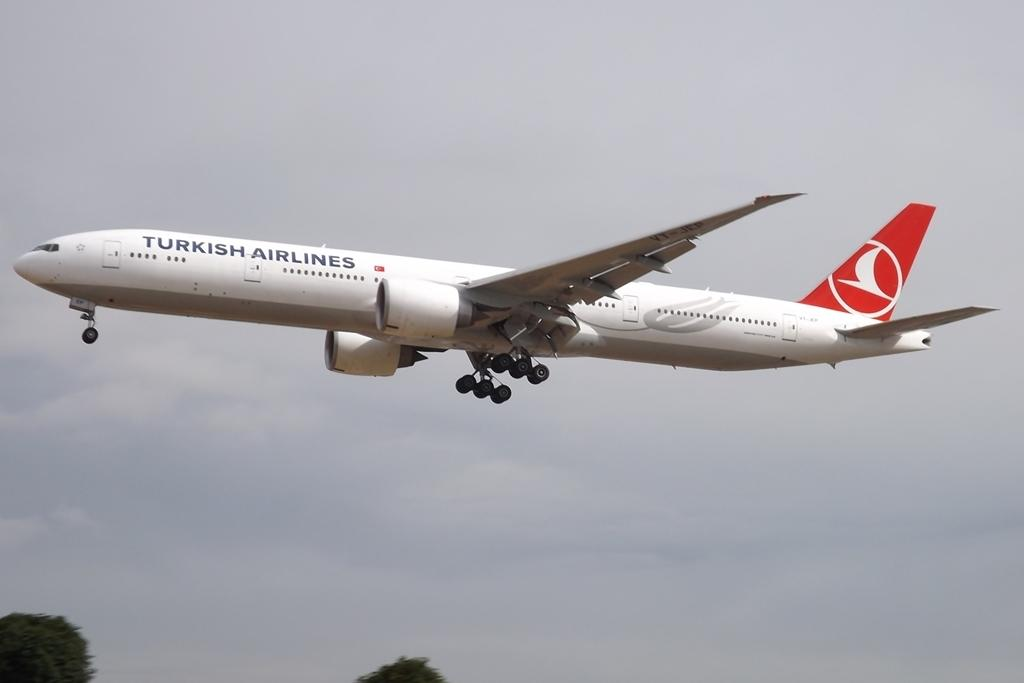Provide a one-sentence caption for the provided image. a very large TURKISH AIRLINES airplane in the air. 